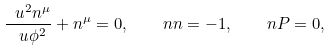<formula> <loc_0><loc_0><loc_500><loc_500>\frac { \ u ^ { 2 } n ^ { \mu } } { \ u \phi ^ { 2 } } + n ^ { \mu } = 0 , \quad n n = - 1 , \quad n P = 0 ,</formula> 